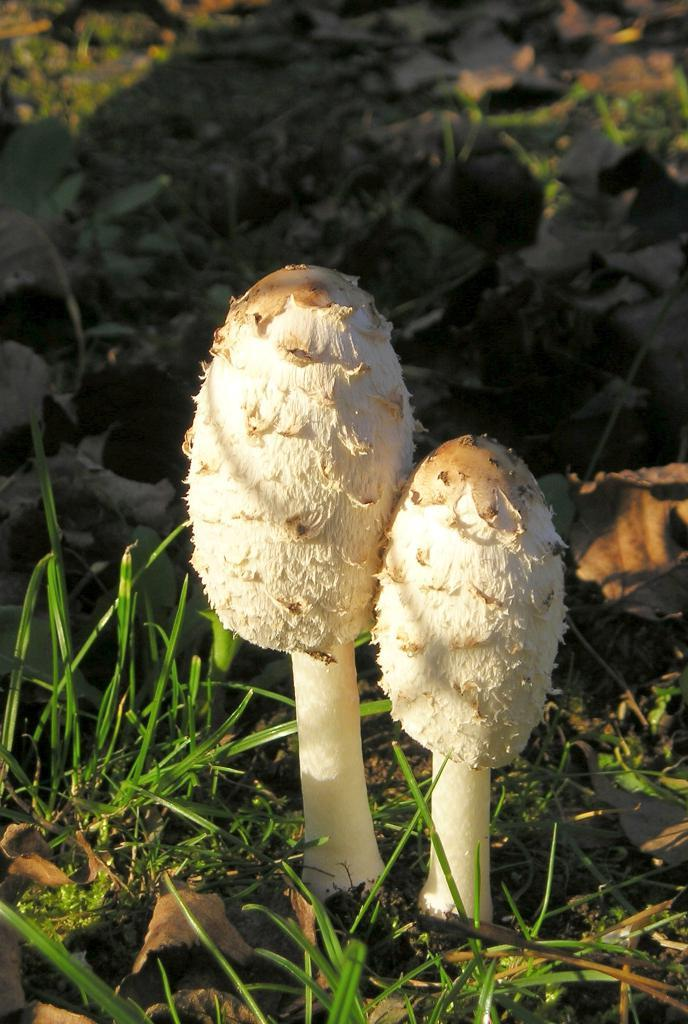What type of vegetation is growing on the grass in the image? There are mushrooms on the surface of the grass in the image. What type of friend can be seen writing a letter in the image? There is no friend or writing activity present in the image; it features mushrooms growing on grass. 